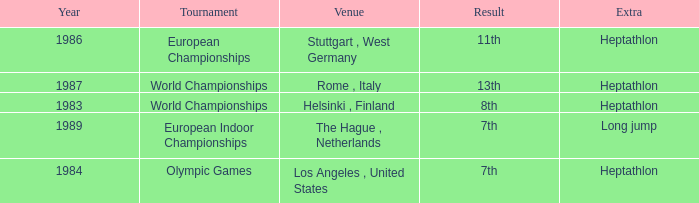Where was the 1984 Olympics hosted? Olympic Games. 